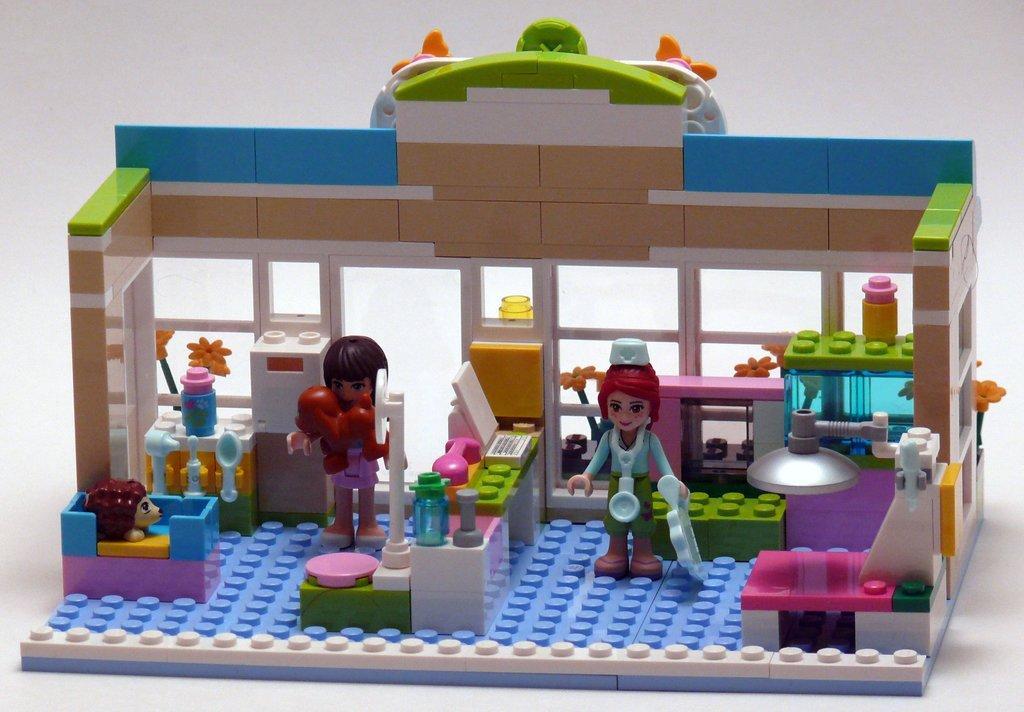In one or two sentences, can you explain what this image depicts? In the center of the image there are Lego toys. 